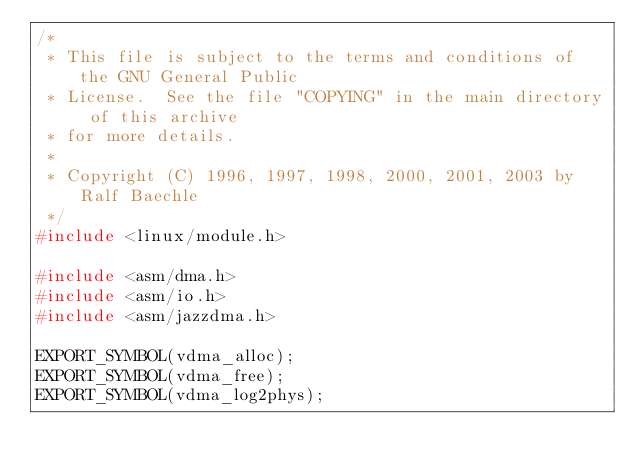<code> <loc_0><loc_0><loc_500><loc_500><_C_>/*
 * This file is subject to the terms and conditions of the GNU General Public
 * License.  See the file "COPYING" in the main directory of this archive
 * for more details.
 *
 * Copyright (C) 1996, 1997, 1998, 2000, 2001, 2003 by Ralf Baechle
 */
#include <linux/module.h>

#include <asm/dma.h>
#include <asm/io.h>
#include <asm/jazzdma.h>

EXPORT_SYMBOL(vdma_alloc);
EXPORT_SYMBOL(vdma_free);
EXPORT_SYMBOL(vdma_log2phys);
</code> 